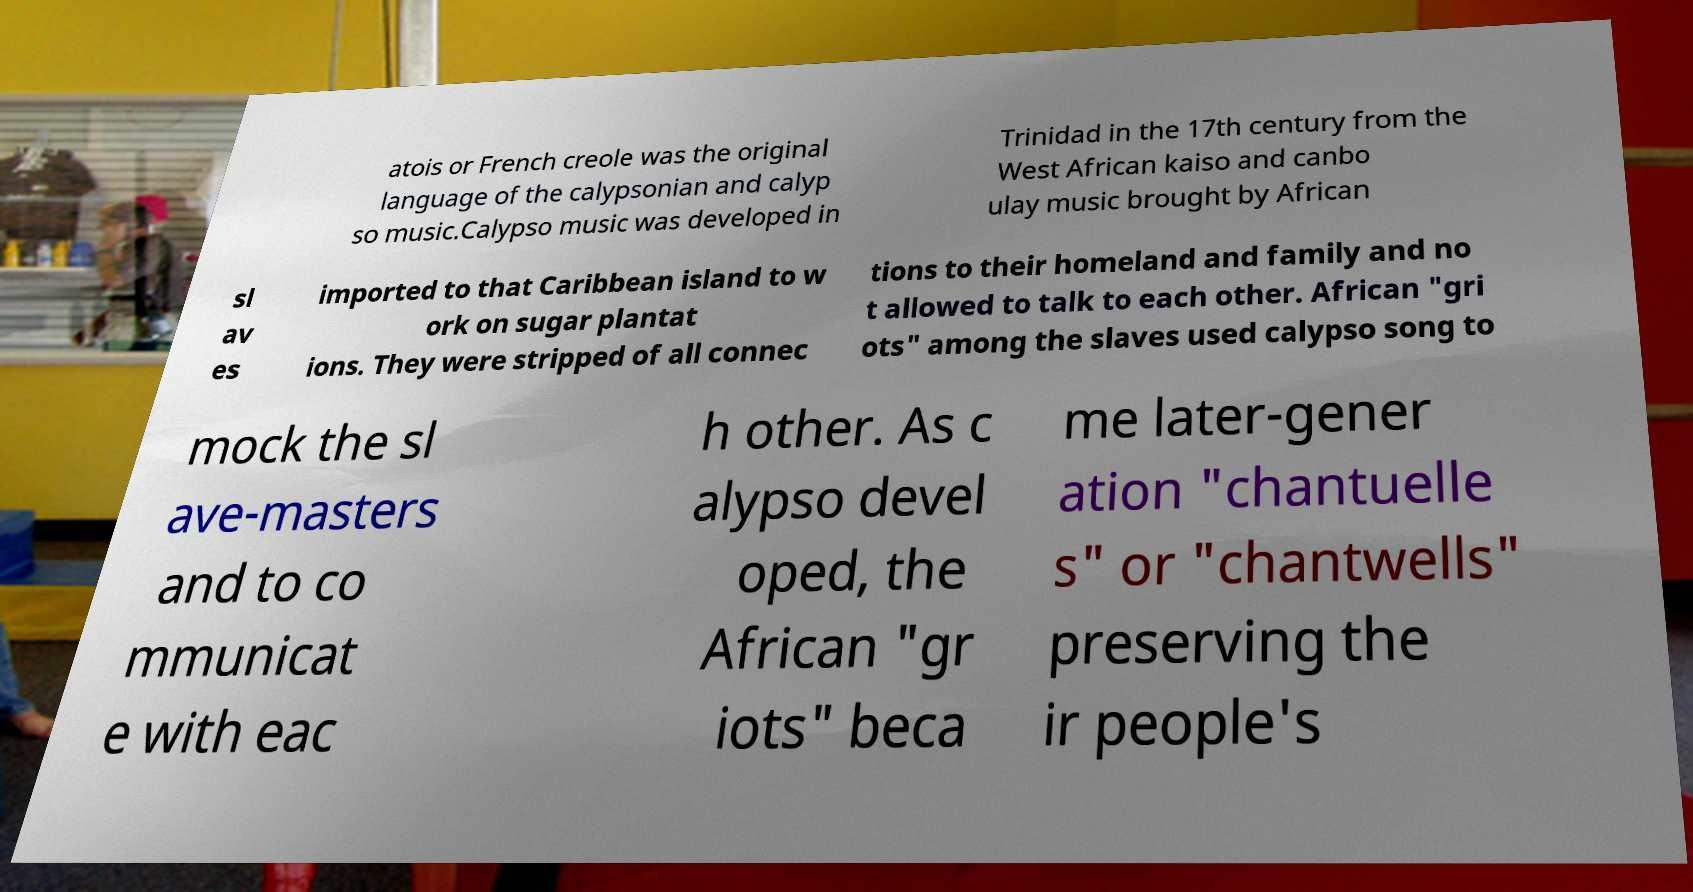Could you assist in decoding the text presented in this image and type it out clearly? atois or French creole was the original language of the calypsonian and calyp so music.Calypso music was developed in Trinidad in the 17th century from the West African kaiso and canbo ulay music brought by African sl av es imported to that Caribbean island to w ork on sugar plantat ions. They were stripped of all connec tions to their homeland and family and no t allowed to talk to each other. African "gri ots" among the slaves used calypso song to mock the sl ave-masters and to co mmunicat e with eac h other. As c alypso devel oped, the African "gr iots" beca me later-gener ation "chantuelle s" or "chantwells" preserving the ir people's 